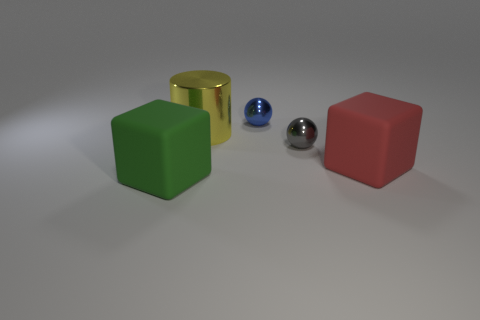Is the shape of the matte thing behind the green object the same as the big matte object to the left of the large metallic thing?
Ensure brevity in your answer.  Yes. Is the size of the green matte cube the same as the red block that is on the right side of the tiny gray ball?
Keep it short and to the point. Yes. Is the number of metal objects greater than the number of large metallic cylinders?
Your answer should be very brief. Yes. Does the green object to the left of the tiny gray sphere have the same material as the thing behind the yellow cylinder?
Your response must be concise. No. What is the big green object made of?
Provide a succinct answer. Rubber. Are there more small objects that are in front of the big yellow metallic thing than green metallic cylinders?
Offer a very short reply. Yes. How many matte blocks are on the right side of the cube in front of the big matte object that is right of the large green rubber block?
Ensure brevity in your answer.  1. There is a object that is behind the large red block and in front of the yellow shiny cylinder; what is it made of?
Provide a succinct answer. Metal. The cylinder is what color?
Offer a terse response. Yellow. Is the number of things to the left of the metallic cylinder greater than the number of large things that are left of the green block?
Your answer should be compact. Yes. 